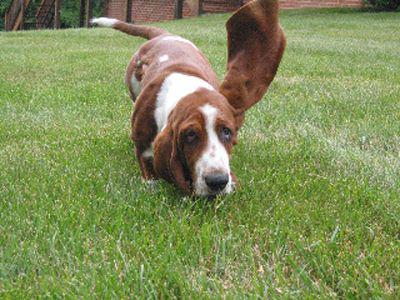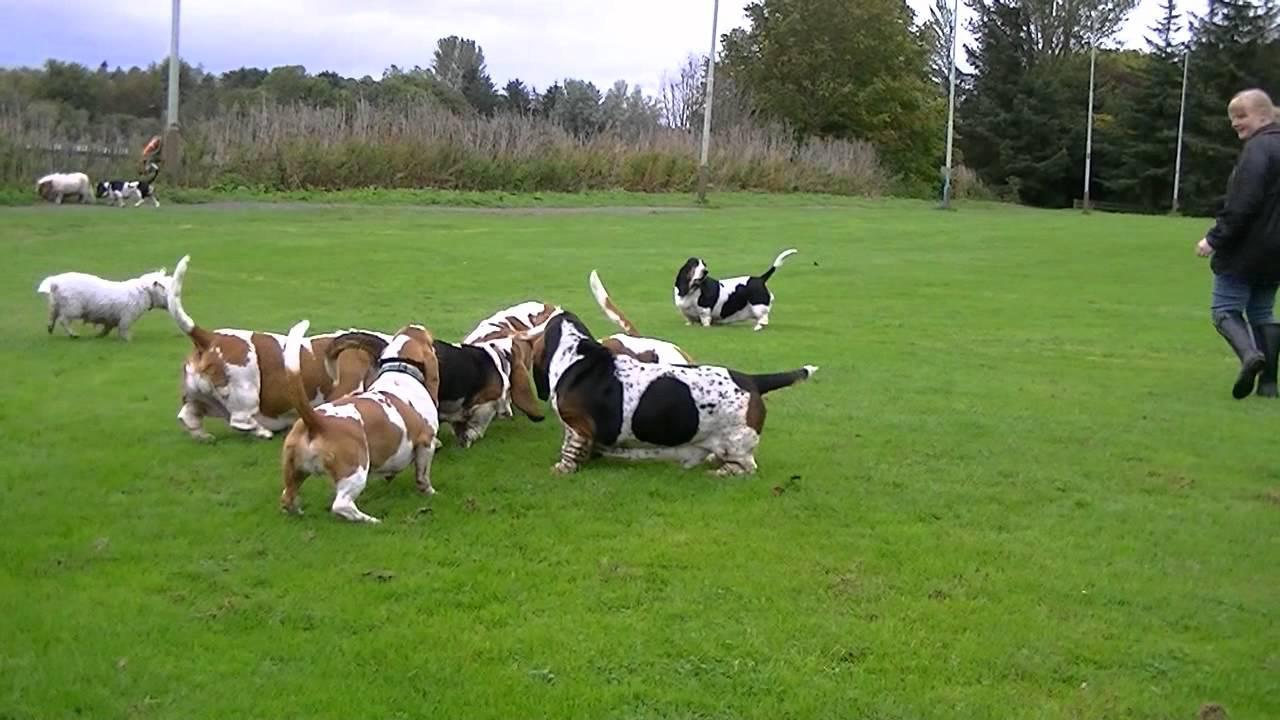The first image is the image on the left, the second image is the image on the right. Assess this claim about the two images: "Every dog on the left is young, every dog on the right is adult.". Correct or not? Answer yes or no. No. 